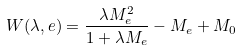<formula> <loc_0><loc_0><loc_500><loc_500>W ( \lambda , e ) = \frac { \lambda M _ { e } ^ { 2 } } { 1 + \lambda M _ { e } } - M _ { e } + M _ { 0 }</formula> 